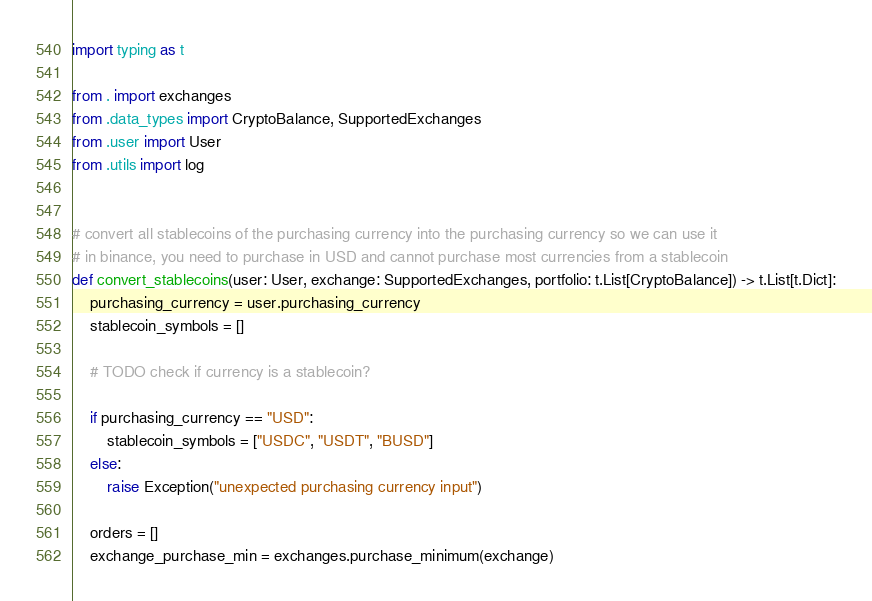Convert code to text. <code><loc_0><loc_0><loc_500><loc_500><_Python_>import typing as t

from . import exchanges
from .data_types import CryptoBalance, SupportedExchanges
from .user import User
from .utils import log


# convert all stablecoins of the purchasing currency into the purchasing currency so we can use it
# in binance, you need to purchase in USD and cannot purchase most currencies from a stablecoin
def convert_stablecoins(user: User, exchange: SupportedExchanges, portfolio: t.List[CryptoBalance]) -> t.List[t.Dict]:
    purchasing_currency = user.purchasing_currency
    stablecoin_symbols = []

    # TODO check if currency is a stablecoin?

    if purchasing_currency == "USD":
        stablecoin_symbols = ["USDC", "USDT", "BUSD"]
    else:
        raise Exception("unexpected purchasing currency input")

    orders = []
    exchange_purchase_min = exchanges.purchase_minimum(exchange)
</code> 